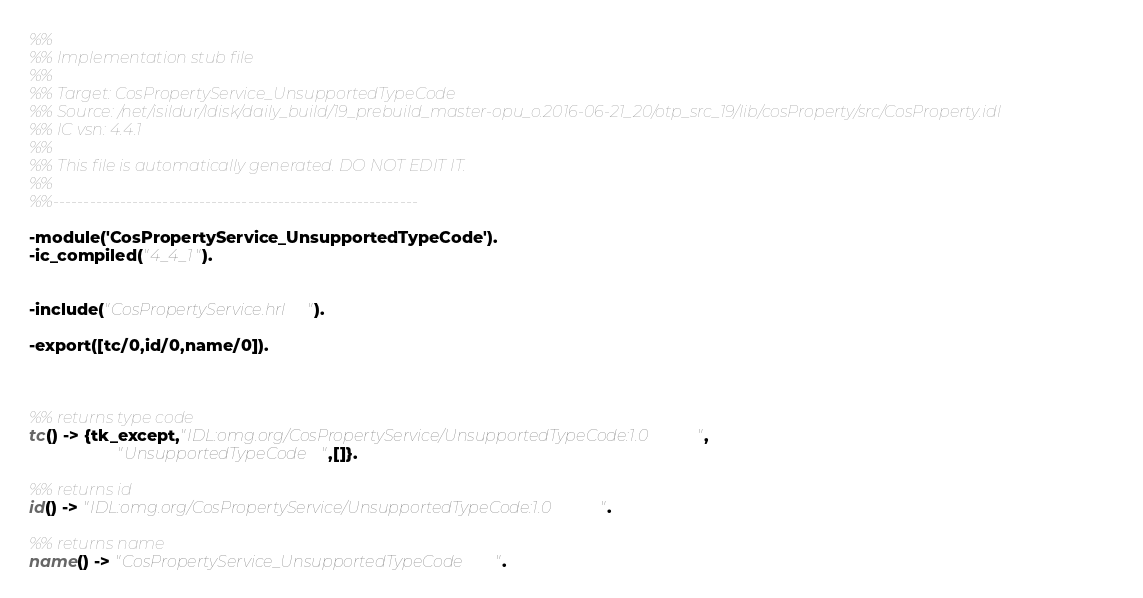Convert code to text. <code><loc_0><loc_0><loc_500><loc_500><_Erlang_>%%
%% Implementation stub file
%% 
%% Target: CosPropertyService_UnsupportedTypeCode
%% Source: /net/isildur/ldisk/daily_build/19_prebuild_master-opu_o.2016-06-21_20/otp_src_19/lib/cosProperty/src/CosProperty.idl
%% IC vsn: 4.4.1
%% 
%% This file is automatically generated. DO NOT EDIT IT.
%%
%%------------------------------------------------------------

-module('CosPropertyService_UnsupportedTypeCode').
-ic_compiled("4_4_1").


-include("CosPropertyService.hrl").

-export([tc/0,id/0,name/0]).



%% returns type code
tc() -> {tk_except,"IDL:omg.org/CosPropertyService/UnsupportedTypeCode:1.0",
                   "UnsupportedTypeCode",[]}.

%% returns id
id() -> "IDL:omg.org/CosPropertyService/UnsupportedTypeCode:1.0".

%% returns name
name() -> "CosPropertyService_UnsupportedTypeCode".



</code> 